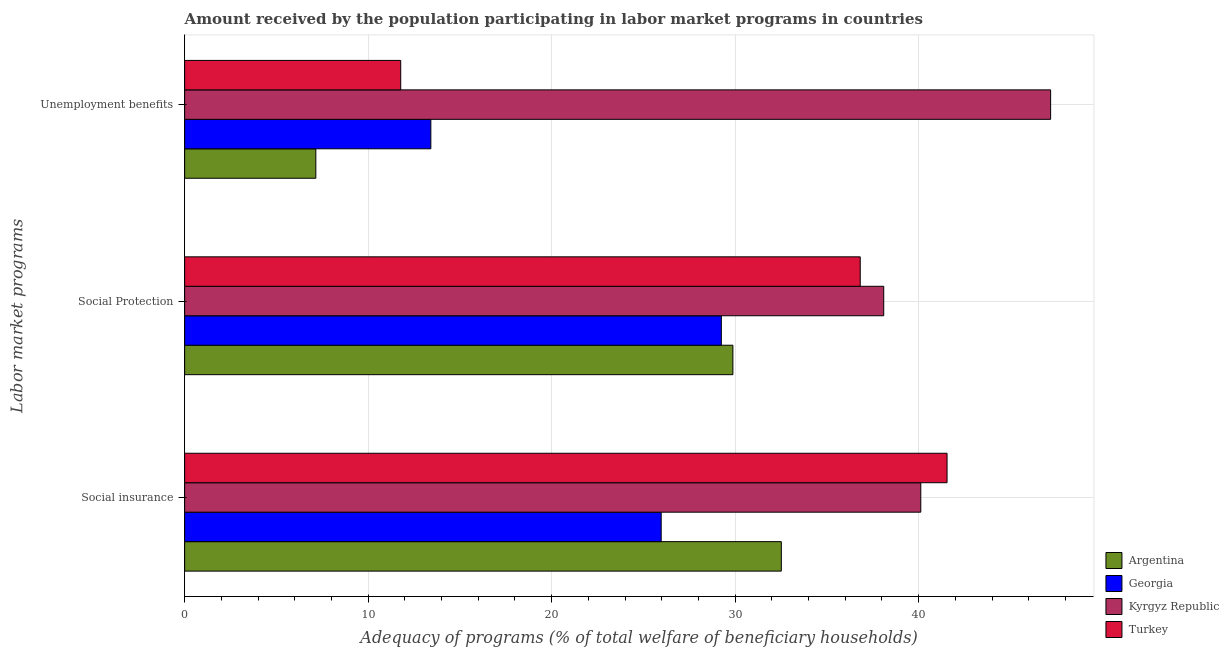Are the number of bars per tick equal to the number of legend labels?
Offer a terse response. Yes. Are the number of bars on each tick of the Y-axis equal?
Your answer should be very brief. Yes. How many bars are there on the 1st tick from the top?
Your answer should be very brief. 4. How many bars are there on the 1st tick from the bottom?
Your response must be concise. 4. What is the label of the 3rd group of bars from the top?
Your response must be concise. Social insurance. What is the amount received by the population participating in unemployment benefits programs in Turkey?
Provide a succinct answer. 11.78. Across all countries, what is the maximum amount received by the population participating in social protection programs?
Keep it short and to the point. 38.1. Across all countries, what is the minimum amount received by the population participating in social protection programs?
Make the answer very short. 29.25. In which country was the amount received by the population participating in social protection programs minimum?
Your answer should be very brief. Georgia. What is the total amount received by the population participating in social protection programs in the graph?
Your response must be concise. 134.04. What is the difference between the amount received by the population participating in unemployment benefits programs in Georgia and that in Argentina?
Provide a succinct answer. 6.27. What is the difference between the amount received by the population participating in social insurance programs in Georgia and the amount received by the population participating in social protection programs in Argentina?
Ensure brevity in your answer.  -3.91. What is the average amount received by the population participating in social protection programs per country?
Keep it short and to the point. 33.51. What is the difference between the amount received by the population participating in social insurance programs and amount received by the population participating in social protection programs in Argentina?
Keep it short and to the point. 2.64. In how many countries, is the amount received by the population participating in social protection programs greater than 4 %?
Your answer should be very brief. 4. What is the ratio of the amount received by the population participating in social insurance programs in Turkey to that in Georgia?
Provide a short and direct response. 1.6. Is the amount received by the population participating in social protection programs in Kyrgyz Republic less than that in Argentina?
Your answer should be very brief. No. What is the difference between the highest and the second highest amount received by the population participating in social insurance programs?
Provide a succinct answer. 1.43. What is the difference between the highest and the lowest amount received by the population participating in social protection programs?
Your answer should be very brief. 8.85. What does the 2nd bar from the top in Social insurance represents?
Keep it short and to the point. Kyrgyz Republic. What does the 3rd bar from the bottom in Social insurance represents?
Offer a very short reply. Kyrgyz Republic. How many countries are there in the graph?
Ensure brevity in your answer.  4. What is the difference between two consecutive major ticks on the X-axis?
Provide a short and direct response. 10. Are the values on the major ticks of X-axis written in scientific E-notation?
Keep it short and to the point. No. Does the graph contain any zero values?
Give a very brief answer. No. Does the graph contain grids?
Give a very brief answer. Yes. How many legend labels are there?
Provide a short and direct response. 4. How are the legend labels stacked?
Ensure brevity in your answer.  Vertical. What is the title of the graph?
Your answer should be compact. Amount received by the population participating in labor market programs in countries. What is the label or title of the X-axis?
Your answer should be very brief. Adequacy of programs (% of total welfare of beneficiary households). What is the label or title of the Y-axis?
Offer a very short reply. Labor market programs. What is the Adequacy of programs (% of total welfare of beneficiary households) of Argentina in Social insurance?
Offer a terse response. 32.52. What is the Adequacy of programs (% of total welfare of beneficiary households) of Georgia in Social insurance?
Provide a short and direct response. 25.97. What is the Adequacy of programs (% of total welfare of beneficiary households) in Kyrgyz Republic in Social insurance?
Your response must be concise. 40.12. What is the Adequacy of programs (% of total welfare of beneficiary households) of Turkey in Social insurance?
Offer a very short reply. 41.55. What is the Adequacy of programs (% of total welfare of beneficiary households) of Argentina in Social Protection?
Give a very brief answer. 29.88. What is the Adequacy of programs (% of total welfare of beneficiary households) of Georgia in Social Protection?
Offer a very short reply. 29.25. What is the Adequacy of programs (% of total welfare of beneficiary households) in Kyrgyz Republic in Social Protection?
Offer a very short reply. 38.1. What is the Adequacy of programs (% of total welfare of beneficiary households) of Turkey in Social Protection?
Give a very brief answer. 36.82. What is the Adequacy of programs (% of total welfare of beneficiary households) of Argentina in Unemployment benefits?
Your answer should be compact. 7.15. What is the Adequacy of programs (% of total welfare of beneficiary households) of Georgia in Unemployment benefits?
Your response must be concise. 13.42. What is the Adequacy of programs (% of total welfare of beneficiary households) in Kyrgyz Republic in Unemployment benefits?
Your answer should be compact. 47.19. What is the Adequacy of programs (% of total welfare of beneficiary households) of Turkey in Unemployment benefits?
Make the answer very short. 11.78. Across all Labor market programs, what is the maximum Adequacy of programs (% of total welfare of beneficiary households) in Argentina?
Provide a succinct answer. 32.52. Across all Labor market programs, what is the maximum Adequacy of programs (% of total welfare of beneficiary households) of Georgia?
Provide a succinct answer. 29.25. Across all Labor market programs, what is the maximum Adequacy of programs (% of total welfare of beneficiary households) in Kyrgyz Republic?
Offer a terse response. 47.19. Across all Labor market programs, what is the maximum Adequacy of programs (% of total welfare of beneficiary households) of Turkey?
Offer a terse response. 41.55. Across all Labor market programs, what is the minimum Adequacy of programs (% of total welfare of beneficiary households) of Argentina?
Your response must be concise. 7.15. Across all Labor market programs, what is the minimum Adequacy of programs (% of total welfare of beneficiary households) in Georgia?
Provide a succinct answer. 13.42. Across all Labor market programs, what is the minimum Adequacy of programs (% of total welfare of beneficiary households) in Kyrgyz Republic?
Your answer should be very brief. 38.1. Across all Labor market programs, what is the minimum Adequacy of programs (% of total welfare of beneficiary households) of Turkey?
Make the answer very short. 11.78. What is the total Adequacy of programs (% of total welfare of beneficiary households) of Argentina in the graph?
Keep it short and to the point. 69.54. What is the total Adequacy of programs (% of total welfare of beneficiary households) in Georgia in the graph?
Provide a short and direct response. 68.63. What is the total Adequacy of programs (% of total welfare of beneficiary households) in Kyrgyz Republic in the graph?
Ensure brevity in your answer.  125.41. What is the total Adequacy of programs (% of total welfare of beneficiary households) of Turkey in the graph?
Give a very brief answer. 90.14. What is the difference between the Adequacy of programs (% of total welfare of beneficiary households) in Argentina in Social insurance and that in Social Protection?
Provide a succinct answer. 2.64. What is the difference between the Adequacy of programs (% of total welfare of beneficiary households) in Georgia in Social insurance and that in Social Protection?
Offer a very short reply. -3.28. What is the difference between the Adequacy of programs (% of total welfare of beneficiary households) in Kyrgyz Republic in Social insurance and that in Social Protection?
Give a very brief answer. 2.02. What is the difference between the Adequacy of programs (% of total welfare of beneficiary households) of Turkey in Social insurance and that in Social Protection?
Ensure brevity in your answer.  4.73. What is the difference between the Adequacy of programs (% of total welfare of beneficiary households) of Argentina in Social insurance and that in Unemployment benefits?
Keep it short and to the point. 25.37. What is the difference between the Adequacy of programs (% of total welfare of beneficiary households) in Georgia in Social insurance and that in Unemployment benefits?
Provide a succinct answer. 12.55. What is the difference between the Adequacy of programs (% of total welfare of beneficiary households) of Kyrgyz Republic in Social insurance and that in Unemployment benefits?
Make the answer very short. -7.08. What is the difference between the Adequacy of programs (% of total welfare of beneficiary households) of Turkey in Social insurance and that in Unemployment benefits?
Ensure brevity in your answer.  29.77. What is the difference between the Adequacy of programs (% of total welfare of beneficiary households) in Argentina in Social Protection and that in Unemployment benefits?
Your answer should be compact. 22.73. What is the difference between the Adequacy of programs (% of total welfare of beneficiary households) of Georgia in Social Protection and that in Unemployment benefits?
Provide a short and direct response. 15.83. What is the difference between the Adequacy of programs (% of total welfare of beneficiary households) in Kyrgyz Republic in Social Protection and that in Unemployment benefits?
Your response must be concise. -9.09. What is the difference between the Adequacy of programs (% of total welfare of beneficiary households) in Turkey in Social Protection and that in Unemployment benefits?
Keep it short and to the point. 25.04. What is the difference between the Adequacy of programs (% of total welfare of beneficiary households) of Argentina in Social insurance and the Adequacy of programs (% of total welfare of beneficiary households) of Georgia in Social Protection?
Keep it short and to the point. 3.27. What is the difference between the Adequacy of programs (% of total welfare of beneficiary households) of Argentina in Social insurance and the Adequacy of programs (% of total welfare of beneficiary households) of Kyrgyz Republic in Social Protection?
Your response must be concise. -5.58. What is the difference between the Adequacy of programs (% of total welfare of beneficiary households) of Georgia in Social insurance and the Adequacy of programs (% of total welfare of beneficiary households) of Kyrgyz Republic in Social Protection?
Provide a short and direct response. -12.13. What is the difference between the Adequacy of programs (% of total welfare of beneficiary households) of Georgia in Social insurance and the Adequacy of programs (% of total welfare of beneficiary households) of Turkey in Social Protection?
Give a very brief answer. -10.85. What is the difference between the Adequacy of programs (% of total welfare of beneficiary households) in Kyrgyz Republic in Social insurance and the Adequacy of programs (% of total welfare of beneficiary households) in Turkey in Social Protection?
Offer a very short reply. 3.3. What is the difference between the Adequacy of programs (% of total welfare of beneficiary households) in Argentina in Social insurance and the Adequacy of programs (% of total welfare of beneficiary households) in Georgia in Unemployment benefits?
Make the answer very short. 19.1. What is the difference between the Adequacy of programs (% of total welfare of beneficiary households) of Argentina in Social insurance and the Adequacy of programs (% of total welfare of beneficiary households) of Kyrgyz Republic in Unemployment benefits?
Your answer should be very brief. -14.68. What is the difference between the Adequacy of programs (% of total welfare of beneficiary households) in Argentina in Social insurance and the Adequacy of programs (% of total welfare of beneficiary households) in Turkey in Unemployment benefits?
Your answer should be very brief. 20.74. What is the difference between the Adequacy of programs (% of total welfare of beneficiary households) in Georgia in Social insurance and the Adequacy of programs (% of total welfare of beneficiary households) in Kyrgyz Republic in Unemployment benefits?
Keep it short and to the point. -21.22. What is the difference between the Adequacy of programs (% of total welfare of beneficiary households) in Georgia in Social insurance and the Adequacy of programs (% of total welfare of beneficiary households) in Turkey in Unemployment benefits?
Keep it short and to the point. 14.19. What is the difference between the Adequacy of programs (% of total welfare of beneficiary households) in Kyrgyz Republic in Social insurance and the Adequacy of programs (% of total welfare of beneficiary households) in Turkey in Unemployment benefits?
Make the answer very short. 28.34. What is the difference between the Adequacy of programs (% of total welfare of beneficiary households) of Argentina in Social Protection and the Adequacy of programs (% of total welfare of beneficiary households) of Georgia in Unemployment benefits?
Your response must be concise. 16.46. What is the difference between the Adequacy of programs (% of total welfare of beneficiary households) of Argentina in Social Protection and the Adequacy of programs (% of total welfare of beneficiary households) of Kyrgyz Republic in Unemployment benefits?
Your response must be concise. -17.32. What is the difference between the Adequacy of programs (% of total welfare of beneficiary households) of Argentina in Social Protection and the Adequacy of programs (% of total welfare of beneficiary households) of Turkey in Unemployment benefits?
Offer a terse response. 18.1. What is the difference between the Adequacy of programs (% of total welfare of beneficiary households) in Georgia in Social Protection and the Adequacy of programs (% of total welfare of beneficiary households) in Kyrgyz Republic in Unemployment benefits?
Your response must be concise. -17.94. What is the difference between the Adequacy of programs (% of total welfare of beneficiary households) of Georgia in Social Protection and the Adequacy of programs (% of total welfare of beneficiary households) of Turkey in Unemployment benefits?
Offer a very short reply. 17.47. What is the difference between the Adequacy of programs (% of total welfare of beneficiary households) in Kyrgyz Republic in Social Protection and the Adequacy of programs (% of total welfare of beneficiary households) in Turkey in Unemployment benefits?
Keep it short and to the point. 26.32. What is the average Adequacy of programs (% of total welfare of beneficiary households) of Argentina per Labor market programs?
Your answer should be very brief. 23.18. What is the average Adequacy of programs (% of total welfare of beneficiary households) of Georgia per Labor market programs?
Make the answer very short. 22.88. What is the average Adequacy of programs (% of total welfare of beneficiary households) of Kyrgyz Republic per Labor market programs?
Your answer should be compact. 41.8. What is the average Adequacy of programs (% of total welfare of beneficiary households) of Turkey per Labor market programs?
Ensure brevity in your answer.  30.05. What is the difference between the Adequacy of programs (% of total welfare of beneficiary households) of Argentina and Adequacy of programs (% of total welfare of beneficiary households) of Georgia in Social insurance?
Provide a short and direct response. 6.55. What is the difference between the Adequacy of programs (% of total welfare of beneficiary households) in Argentina and Adequacy of programs (% of total welfare of beneficiary households) in Kyrgyz Republic in Social insurance?
Provide a succinct answer. -7.6. What is the difference between the Adequacy of programs (% of total welfare of beneficiary households) in Argentina and Adequacy of programs (% of total welfare of beneficiary households) in Turkey in Social insurance?
Make the answer very short. -9.03. What is the difference between the Adequacy of programs (% of total welfare of beneficiary households) of Georgia and Adequacy of programs (% of total welfare of beneficiary households) of Kyrgyz Republic in Social insurance?
Your response must be concise. -14.15. What is the difference between the Adequacy of programs (% of total welfare of beneficiary households) of Georgia and Adequacy of programs (% of total welfare of beneficiary households) of Turkey in Social insurance?
Provide a succinct answer. -15.58. What is the difference between the Adequacy of programs (% of total welfare of beneficiary households) of Kyrgyz Republic and Adequacy of programs (% of total welfare of beneficiary households) of Turkey in Social insurance?
Your answer should be compact. -1.43. What is the difference between the Adequacy of programs (% of total welfare of beneficiary households) of Argentina and Adequacy of programs (% of total welfare of beneficiary households) of Georgia in Social Protection?
Your answer should be compact. 0.63. What is the difference between the Adequacy of programs (% of total welfare of beneficiary households) in Argentina and Adequacy of programs (% of total welfare of beneficiary households) in Kyrgyz Republic in Social Protection?
Offer a terse response. -8.22. What is the difference between the Adequacy of programs (% of total welfare of beneficiary households) in Argentina and Adequacy of programs (% of total welfare of beneficiary households) in Turkey in Social Protection?
Keep it short and to the point. -6.94. What is the difference between the Adequacy of programs (% of total welfare of beneficiary households) of Georgia and Adequacy of programs (% of total welfare of beneficiary households) of Kyrgyz Republic in Social Protection?
Your answer should be very brief. -8.85. What is the difference between the Adequacy of programs (% of total welfare of beneficiary households) of Georgia and Adequacy of programs (% of total welfare of beneficiary households) of Turkey in Social Protection?
Your answer should be compact. -7.57. What is the difference between the Adequacy of programs (% of total welfare of beneficiary households) in Kyrgyz Republic and Adequacy of programs (% of total welfare of beneficiary households) in Turkey in Social Protection?
Offer a terse response. 1.28. What is the difference between the Adequacy of programs (% of total welfare of beneficiary households) of Argentina and Adequacy of programs (% of total welfare of beneficiary households) of Georgia in Unemployment benefits?
Your response must be concise. -6.27. What is the difference between the Adequacy of programs (% of total welfare of beneficiary households) in Argentina and Adequacy of programs (% of total welfare of beneficiary households) in Kyrgyz Republic in Unemployment benefits?
Make the answer very short. -40.04. What is the difference between the Adequacy of programs (% of total welfare of beneficiary households) of Argentina and Adequacy of programs (% of total welfare of beneficiary households) of Turkey in Unemployment benefits?
Ensure brevity in your answer.  -4.63. What is the difference between the Adequacy of programs (% of total welfare of beneficiary households) of Georgia and Adequacy of programs (% of total welfare of beneficiary households) of Kyrgyz Republic in Unemployment benefits?
Offer a very short reply. -33.77. What is the difference between the Adequacy of programs (% of total welfare of beneficiary households) in Georgia and Adequacy of programs (% of total welfare of beneficiary households) in Turkey in Unemployment benefits?
Provide a short and direct response. 1.64. What is the difference between the Adequacy of programs (% of total welfare of beneficiary households) of Kyrgyz Republic and Adequacy of programs (% of total welfare of beneficiary households) of Turkey in Unemployment benefits?
Your answer should be compact. 35.42. What is the ratio of the Adequacy of programs (% of total welfare of beneficiary households) of Argentina in Social insurance to that in Social Protection?
Your answer should be very brief. 1.09. What is the ratio of the Adequacy of programs (% of total welfare of beneficiary households) of Georgia in Social insurance to that in Social Protection?
Make the answer very short. 0.89. What is the ratio of the Adequacy of programs (% of total welfare of beneficiary households) of Kyrgyz Republic in Social insurance to that in Social Protection?
Keep it short and to the point. 1.05. What is the ratio of the Adequacy of programs (% of total welfare of beneficiary households) in Turkey in Social insurance to that in Social Protection?
Your response must be concise. 1.13. What is the ratio of the Adequacy of programs (% of total welfare of beneficiary households) of Argentina in Social insurance to that in Unemployment benefits?
Ensure brevity in your answer.  4.55. What is the ratio of the Adequacy of programs (% of total welfare of beneficiary households) of Georgia in Social insurance to that in Unemployment benefits?
Provide a succinct answer. 1.94. What is the ratio of the Adequacy of programs (% of total welfare of beneficiary households) of Turkey in Social insurance to that in Unemployment benefits?
Your answer should be very brief. 3.53. What is the ratio of the Adequacy of programs (% of total welfare of beneficiary households) of Argentina in Social Protection to that in Unemployment benefits?
Your response must be concise. 4.18. What is the ratio of the Adequacy of programs (% of total welfare of beneficiary households) in Georgia in Social Protection to that in Unemployment benefits?
Your answer should be very brief. 2.18. What is the ratio of the Adequacy of programs (% of total welfare of beneficiary households) of Kyrgyz Republic in Social Protection to that in Unemployment benefits?
Offer a terse response. 0.81. What is the ratio of the Adequacy of programs (% of total welfare of beneficiary households) of Turkey in Social Protection to that in Unemployment benefits?
Offer a terse response. 3.13. What is the difference between the highest and the second highest Adequacy of programs (% of total welfare of beneficiary households) in Argentina?
Your answer should be very brief. 2.64. What is the difference between the highest and the second highest Adequacy of programs (% of total welfare of beneficiary households) in Georgia?
Give a very brief answer. 3.28. What is the difference between the highest and the second highest Adequacy of programs (% of total welfare of beneficiary households) in Kyrgyz Republic?
Your response must be concise. 7.08. What is the difference between the highest and the second highest Adequacy of programs (% of total welfare of beneficiary households) in Turkey?
Provide a succinct answer. 4.73. What is the difference between the highest and the lowest Adequacy of programs (% of total welfare of beneficiary households) in Argentina?
Provide a short and direct response. 25.37. What is the difference between the highest and the lowest Adequacy of programs (% of total welfare of beneficiary households) of Georgia?
Keep it short and to the point. 15.83. What is the difference between the highest and the lowest Adequacy of programs (% of total welfare of beneficiary households) of Kyrgyz Republic?
Your answer should be compact. 9.09. What is the difference between the highest and the lowest Adequacy of programs (% of total welfare of beneficiary households) in Turkey?
Give a very brief answer. 29.77. 